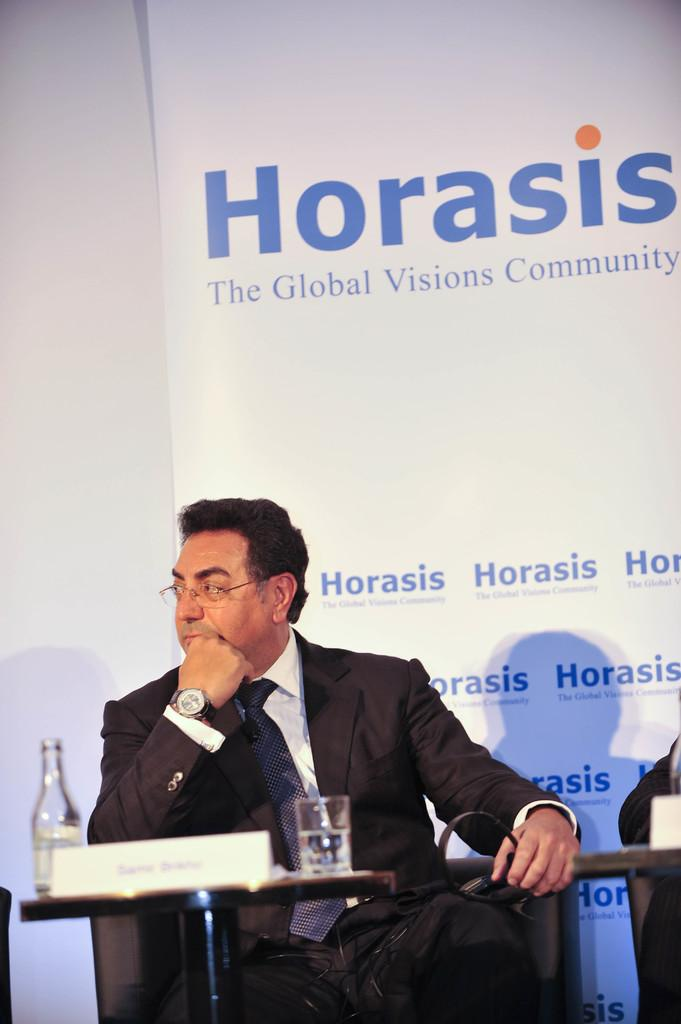What is the person in the image doing? The person is sitting in the image. Where is the person sitting in relation to the table? The person is sitting in front of a table. What objects are on the table in the image? There is a bottle and a glass on the table in the image. What can be seen in the background of the image? There is a banner attached to the wall in the background. What type of education can be seen in the image? There is no reference to education in the image; it features a person sitting in front of a table with a bottle and a glass. How many birds are visible in the image? There are no birds present in the image. 